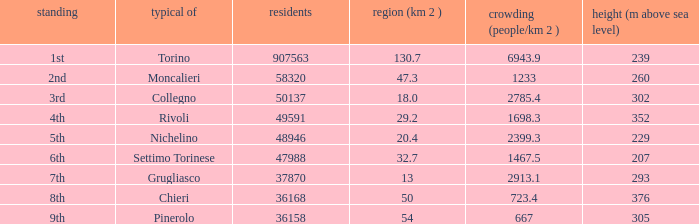What rank is the common with an area of 47.3 km^2? 2nd. 